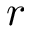<formula> <loc_0><loc_0><loc_500><loc_500>r</formula> 